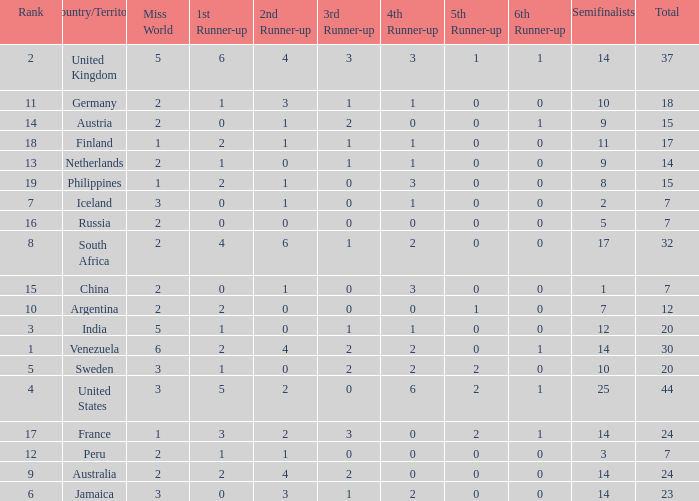What is Venezuela's total rank? 30.0. 